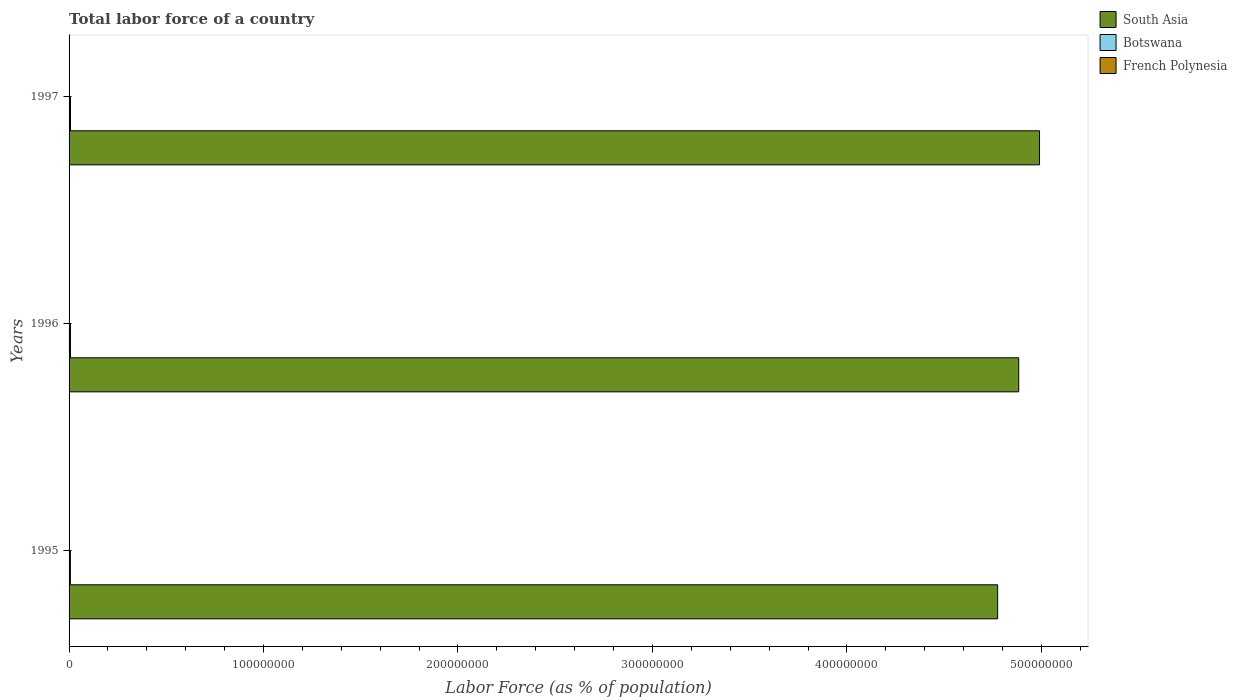Are the number of bars on each tick of the Y-axis equal?
Your answer should be compact. Yes. How many bars are there on the 1st tick from the top?
Offer a terse response. 3. In how many cases, is the number of bars for a given year not equal to the number of legend labels?
Provide a short and direct response. 0. What is the percentage of labor force in Botswana in 1996?
Your response must be concise. 7.08e+05. Across all years, what is the maximum percentage of labor force in Botswana?
Make the answer very short. 7.32e+05. Across all years, what is the minimum percentage of labor force in South Asia?
Give a very brief answer. 4.78e+08. In which year was the percentage of labor force in Botswana minimum?
Offer a terse response. 1995. What is the total percentage of labor force in Botswana in the graph?
Keep it short and to the point. 2.12e+06. What is the difference between the percentage of labor force in South Asia in 1996 and that in 1997?
Provide a succinct answer. -1.07e+07. What is the difference between the percentage of labor force in South Asia in 1997 and the percentage of labor force in Botswana in 1995?
Your answer should be very brief. 4.98e+08. What is the average percentage of labor force in Botswana per year?
Offer a very short reply. 7.08e+05. In the year 1995, what is the difference between the percentage of labor force in French Polynesia and percentage of labor force in South Asia?
Provide a short and direct response. -4.77e+08. What is the ratio of the percentage of labor force in French Polynesia in 1996 to that in 1997?
Your answer should be compact. 0.98. Is the percentage of labor force in Botswana in 1995 less than that in 1996?
Provide a succinct answer. Yes. What is the difference between the highest and the second highest percentage of labor force in Botswana?
Your answer should be compact. 2.37e+04. What is the difference between the highest and the lowest percentage of labor force in Botswana?
Your response must be concise. 4.73e+04. Is the sum of the percentage of labor force in French Polynesia in 1995 and 1996 greater than the maximum percentage of labor force in South Asia across all years?
Provide a short and direct response. No. What does the 1st bar from the top in 1995 represents?
Ensure brevity in your answer.  French Polynesia. What does the 2nd bar from the bottom in 1997 represents?
Offer a very short reply. Botswana. Is it the case that in every year, the sum of the percentage of labor force in French Polynesia and percentage of labor force in Botswana is greater than the percentage of labor force in South Asia?
Keep it short and to the point. No. How many years are there in the graph?
Offer a very short reply. 3. Are the values on the major ticks of X-axis written in scientific E-notation?
Offer a very short reply. No. Does the graph contain grids?
Keep it short and to the point. No. Where does the legend appear in the graph?
Offer a very short reply. Top right. What is the title of the graph?
Ensure brevity in your answer.  Total labor force of a country. What is the label or title of the X-axis?
Your answer should be very brief. Labor Force (as % of population). What is the label or title of the Y-axis?
Make the answer very short. Years. What is the Labor Force (as % of population) of South Asia in 1995?
Your answer should be compact. 4.78e+08. What is the Labor Force (as % of population) of Botswana in 1995?
Provide a succinct answer. 6.84e+05. What is the Labor Force (as % of population) of French Polynesia in 1995?
Ensure brevity in your answer.  8.45e+04. What is the Labor Force (as % of population) of South Asia in 1996?
Make the answer very short. 4.88e+08. What is the Labor Force (as % of population) in Botswana in 1996?
Keep it short and to the point. 7.08e+05. What is the Labor Force (as % of population) of French Polynesia in 1996?
Give a very brief answer. 8.65e+04. What is the Labor Force (as % of population) of South Asia in 1997?
Offer a very short reply. 4.99e+08. What is the Labor Force (as % of population) in Botswana in 1997?
Keep it short and to the point. 7.32e+05. What is the Labor Force (as % of population) of French Polynesia in 1997?
Make the answer very short. 8.86e+04. Across all years, what is the maximum Labor Force (as % of population) in South Asia?
Your response must be concise. 4.99e+08. Across all years, what is the maximum Labor Force (as % of population) of Botswana?
Your answer should be very brief. 7.32e+05. Across all years, what is the maximum Labor Force (as % of population) of French Polynesia?
Your response must be concise. 8.86e+04. Across all years, what is the minimum Labor Force (as % of population) of South Asia?
Give a very brief answer. 4.78e+08. Across all years, what is the minimum Labor Force (as % of population) in Botswana?
Your response must be concise. 6.84e+05. Across all years, what is the minimum Labor Force (as % of population) in French Polynesia?
Your response must be concise. 8.45e+04. What is the total Labor Force (as % of population) of South Asia in the graph?
Offer a terse response. 1.46e+09. What is the total Labor Force (as % of population) of Botswana in the graph?
Your answer should be compact. 2.12e+06. What is the total Labor Force (as % of population) in French Polynesia in the graph?
Give a very brief answer. 2.60e+05. What is the difference between the Labor Force (as % of population) of South Asia in 1995 and that in 1996?
Your answer should be compact. -1.08e+07. What is the difference between the Labor Force (as % of population) in Botswana in 1995 and that in 1996?
Make the answer very short. -2.35e+04. What is the difference between the Labor Force (as % of population) of French Polynesia in 1995 and that in 1996?
Give a very brief answer. -1924. What is the difference between the Labor Force (as % of population) of South Asia in 1995 and that in 1997?
Keep it short and to the point. -2.15e+07. What is the difference between the Labor Force (as % of population) in Botswana in 1995 and that in 1997?
Your answer should be very brief. -4.73e+04. What is the difference between the Labor Force (as % of population) of French Polynesia in 1995 and that in 1997?
Make the answer very short. -4070. What is the difference between the Labor Force (as % of population) of South Asia in 1996 and that in 1997?
Your response must be concise. -1.07e+07. What is the difference between the Labor Force (as % of population) of Botswana in 1996 and that in 1997?
Offer a very short reply. -2.37e+04. What is the difference between the Labor Force (as % of population) in French Polynesia in 1996 and that in 1997?
Your answer should be very brief. -2146. What is the difference between the Labor Force (as % of population) in South Asia in 1995 and the Labor Force (as % of population) in Botswana in 1996?
Your answer should be compact. 4.77e+08. What is the difference between the Labor Force (as % of population) of South Asia in 1995 and the Labor Force (as % of population) of French Polynesia in 1996?
Your answer should be compact. 4.77e+08. What is the difference between the Labor Force (as % of population) in Botswana in 1995 and the Labor Force (as % of population) in French Polynesia in 1996?
Provide a short and direct response. 5.98e+05. What is the difference between the Labor Force (as % of population) in South Asia in 1995 and the Labor Force (as % of population) in Botswana in 1997?
Provide a succinct answer. 4.77e+08. What is the difference between the Labor Force (as % of population) in South Asia in 1995 and the Labor Force (as % of population) in French Polynesia in 1997?
Your response must be concise. 4.77e+08. What is the difference between the Labor Force (as % of population) of Botswana in 1995 and the Labor Force (as % of population) of French Polynesia in 1997?
Your answer should be very brief. 5.96e+05. What is the difference between the Labor Force (as % of population) in South Asia in 1996 and the Labor Force (as % of population) in Botswana in 1997?
Provide a succinct answer. 4.88e+08. What is the difference between the Labor Force (as % of population) of South Asia in 1996 and the Labor Force (as % of population) of French Polynesia in 1997?
Keep it short and to the point. 4.88e+08. What is the difference between the Labor Force (as % of population) in Botswana in 1996 and the Labor Force (as % of population) in French Polynesia in 1997?
Offer a terse response. 6.19e+05. What is the average Labor Force (as % of population) of South Asia per year?
Your answer should be very brief. 4.88e+08. What is the average Labor Force (as % of population) of Botswana per year?
Make the answer very short. 7.08e+05. What is the average Labor Force (as % of population) of French Polynesia per year?
Your answer should be very brief. 8.65e+04. In the year 1995, what is the difference between the Labor Force (as % of population) of South Asia and Labor Force (as % of population) of Botswana?
Give a very brief answer. 4.77e+08. In the year 1995, what is the difference between the Labor Force (as % of population) in South Asia and Labor Force (as % of population) in French Polynesia?
Offer a very short reply. 4.77e+08. In the year 1995, what is the difference between the Labor Force (as % of population) of Botswana and Labor Force (as % of population) of French Polynesia?
Offer a very short reply. 6.00e+05. In the year 1996, what is the difference between the Labor Force (as % of population) of South Asia and Labor Force (as % of population) of Botswana?
Provide a short and direct response. 4.88e+08. In the year 1996, what is the difference between the Labor Force (as % of population) in South Asia and Labor Force (as % of population) in French Polynesia?
Keep it short and to the point. 4.88e+08. In the year 1996, what is the difference between the Labor Force (as % of population) of Botswana and Labor Force (as % of population) of French Polynesia?
Provide a short and direct response. 6.21e+05. In the year 1997, what is the difference between the Labor Force (as % of population) in South Asia and Labor Force (as % of population) in Botswana?
Make the answer very short. 4.98e+08. In the year 1997, what is the difference between the Labor Force (as % of population) of South Asia and Labor Force (as % of population) of French Polynesia?
Your answer should be compact. 4.99e+08. In the year 1997, what is the difference between the Labor Force (as % of population) in Botswana and Labor Force (as % of population) in French Polynesia?
Ensure brevity in your answer.  6.43e+05. What is the ratio of the Labor Force (as % of population) of South Asia in 1995 to that in 1996?
Provide a short and direct response. 0.98. What is the ratio of the Labor Force (as % of population) in Botswana in 1995 to that in 1996?
Your answer should be compact. 0.97. What is the ratio of the Labor Force (as % of population) in French Polynesia in 1995 to that in 1996?
Offer a terse response. 0.98. What is the ratio of the Labor Force (as % of population) of South Asia in 1995 to that in 1997?
Offer a terse response. 0.96. What is the ratio of the Labor Force (as % of population) in Botswana in 1995 to that in 1997?
Your response must be concise. 0.94. What is the ratio of the Labor Force (as % of population) in French Polynesia in 1995 to that in 1997?
Make the answer very short. 0.95. What is the ratio of the Labor Force (as % of population) of South Asia in 1996 to that in 1997?
Your answer should be compact. 0.98. What is the ratio of the Labor Force (as % of population) in Botswana in 1996 to that in 1997?
Your response must be concise. 0.97. What is the ratio of the Labor Force (as % of population) of French Polynesia in 1996 to that in 1997?
Give a very brief answer. 0.98. What is the difference between the highest and the second highest Labor Force (as % of population) in South Asia?
Offer a terse response. 1.07e+07. What is the difference between the highest and the second highest Labor Force (as % of population) in Botswana?
Your answer should be very brief. 2.37e+04. What is the difference between the highest and the second highest Labor Force (as % of population) in French Polynesia?
Provide a short and direct response. 2146. What is the difference between the highest and the lowest Labor Force (as % of population) of South Asia?
Your answer should be compact. 2.15e+07. What is the difference between the highest and the lowest Labor Force (as % of population) of Botswana?
Keep it short and to the point. 4.73e+04. What is the difference between the highest and the lowest Labor Force (as % of population) of French Polynesia?
Give a very brief answer. 4070. 